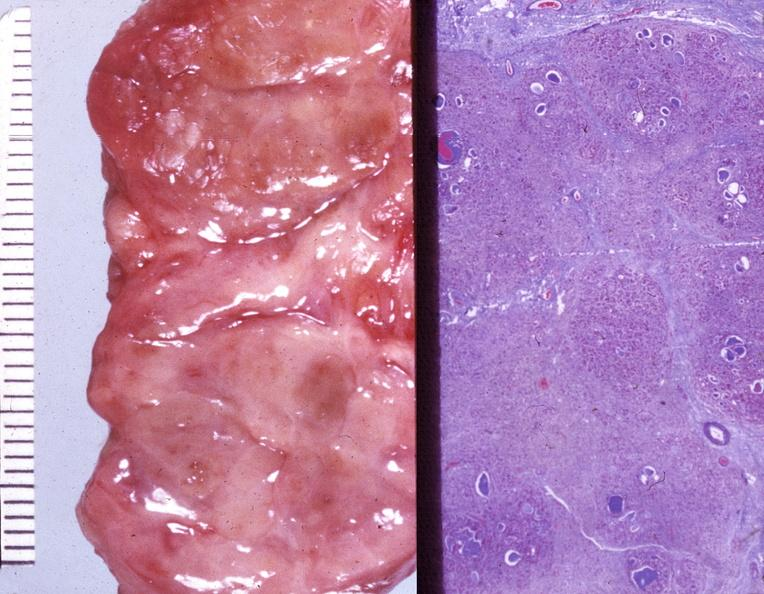does this image show thyroid, hashimotos?
Answer the question using a single word or phrase. Yes 